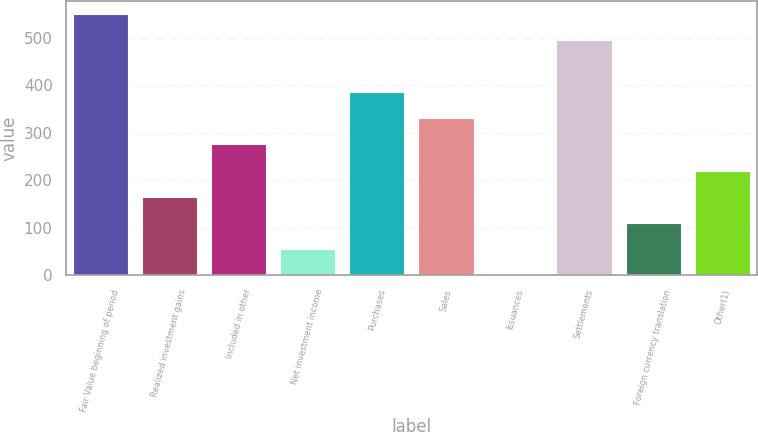Convert chart. <chart><loc_0><loc_0><loc_500><loc_500><bar_chart><fcel>Fair Value beginning of period<fcel>Realized investment gains<fcel>Included in other<fcel>Net investment income<fcel>Purchases<fcel>Sales<fcel>Issuances<fcel>Settlements<fcel>Foreign currency translation<fcel>Other(1)<nl><fcel>549.98<fcel>165.61<fcel>275.43<fcel>55.79<fcel>385.25<fcel>330.34<fcel>0.88<fcel>495.07<fcel>110.7<fcel>220.52<nl></chart> 